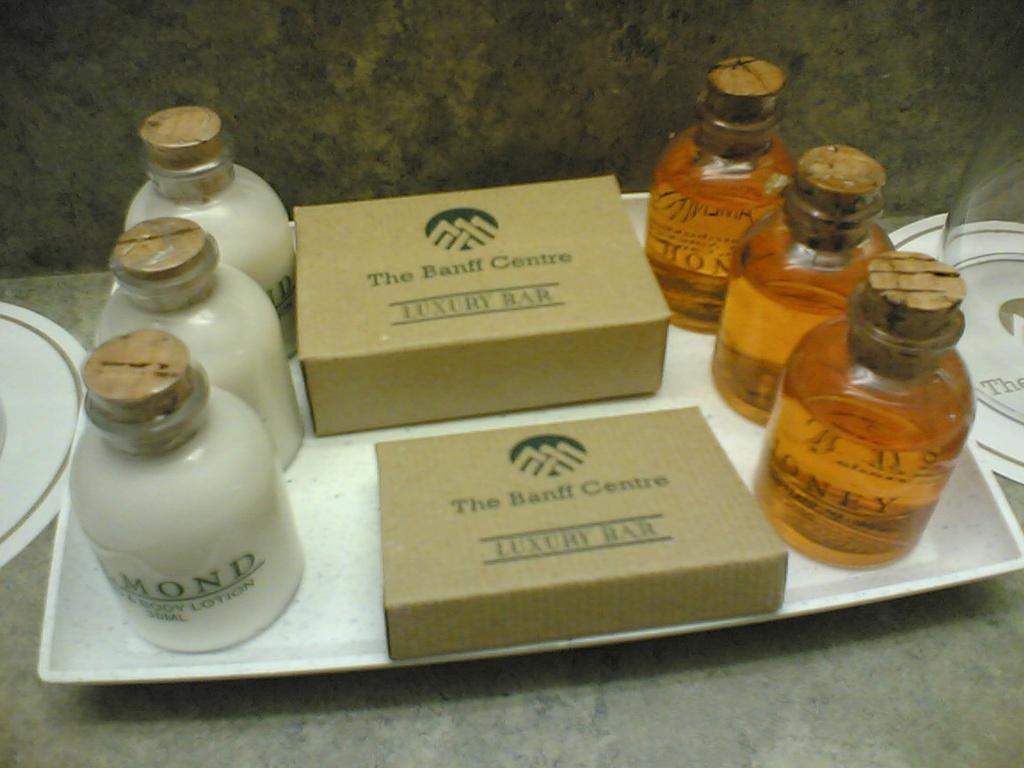Provide a one-sentence caption for the provided image. A hotel essential bath and shower kit from the Banff Centre including a luxury bar, lotion, and soap. 